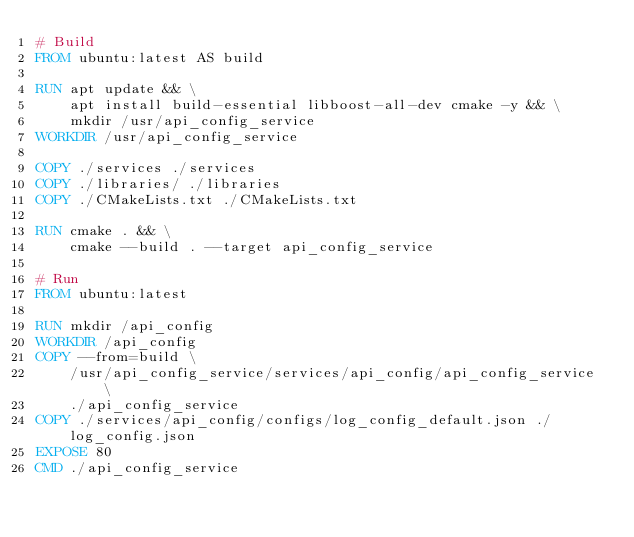Convert code to text. <code><loc_0><loc_0><loc_500><loc_500><_Dockerfile_># Build
FROM ubuntu:latest AS build

RUN apt update && \
    apt install build-essential libboost-all-dev cmake -y && \
    mkdir /usr/api_config_service
WORKDIR /usr/api_config_service

COPY ./services ./services
COPY ./libraries/ ./libraries
COPY ./CMakeLists.txt ./CMakeLists.txt

RUN cmake . && \
    cmake --build . --target api_config_service

# Run
FROM ubuntu:latest

RUN mkdir /api_config
WORKDIR /api_config
COPY --from=build \
    /usr/api_config_service/services/api_config/api_config_service \
    ./api_config_service
COPY ./services/api_config/configs/log_config_default.json ./log_config.json
EXPOSE 80
CMD ./api_config_service</code> 